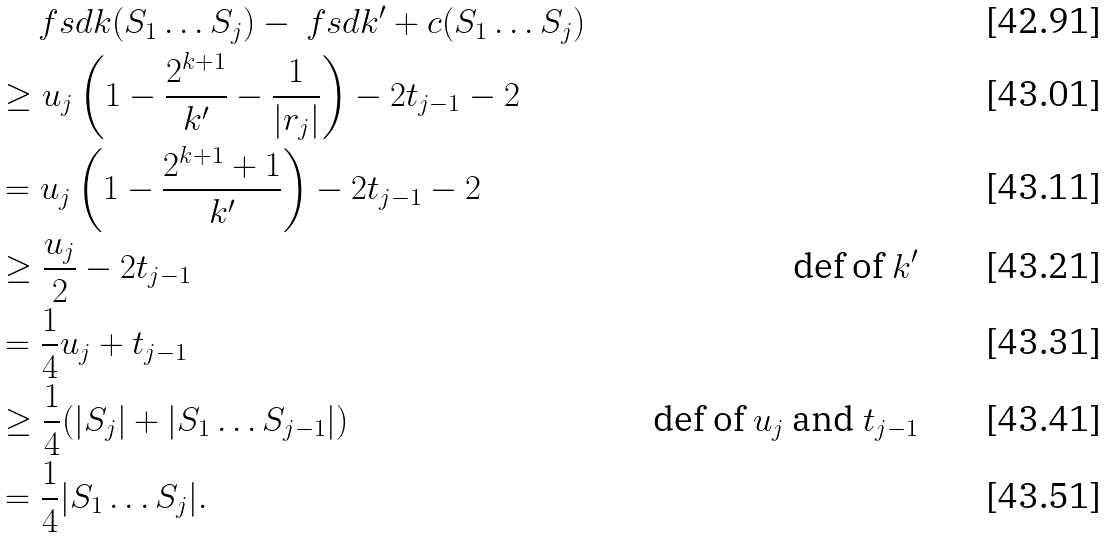<formula> <loc_0><loc_0><loc_500><loc_500>& \quad \ f s d { k } ( S _ { 1 } \dots S _ { j } ) - \ f s d { k ^ { \prime } + c } ( S _ { 1 } \dots S _ { j } ) \\ & \geq u _ { j } \left ( 1 - \frac { 2 ^ { k + 1 } } { k ^ { \prime } } - \frac { 1 } { | r _ { j } | } \right ) - 2 t _ { j - 1 } - 2 \\ & = u _ { j } \left ( 1 - \frac { 2 ^ { k + 1 } + 1 } { k ^ { \prime } } \right ) - 2 t _ { j - 1 } - 2 \\ & \geq \frac { u _ { j } } { 2 } - 2 t _ { j - 1 } & \text {def of $k^{\prime}$} \\ & = \frac { 1 } { 4 } u _ { j } + t _ { j - 1 } \\ & \geq \frac { 1 } { 4 } ( | S _ { j } | + | S _ { 1 } \dots S _ { j - 1 } | ) & \text {def of $u_{j}$ and $t_{j-1}$} \\ & = \frac { 1 } { 4 } | S _ { 1 } \dots S _ { j } | .</formula> 